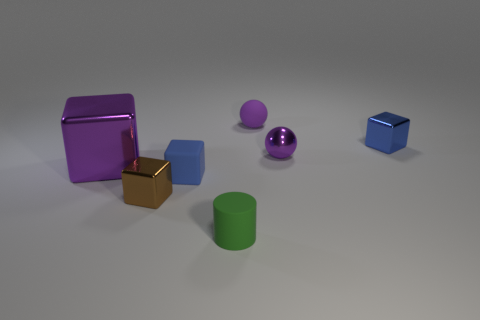Subtract all tiny brown blocks. How many blocks are left? 3 Subtract all yellow balls. How many blue blocks are left? 2 Add 2 small rubber cubes. How many objects exist? 9 Subtract all purple cubes. How many cubes are left? 3 Subtract 2 blocks. How many blocks are left? 2 Subtract all blocks. How many objects are left? 3 Subtract all red blocks. Subtract all red balls. How many blocks are left? 4 Add 1 small green shiny cubes. How many small green shiny cubes exist? 1 Subtract 0 blue spheres. How many objects are left? 7 Subtract all purple shiny balls. Subtract all tiny brown metallic cubes. How many objects are left? 5 